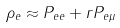<formula> <loc_0><loc_0><loc_500><loc_500>\rho _ { e } \approx P _ { e e } + r P _ { e \mu }</formula> 